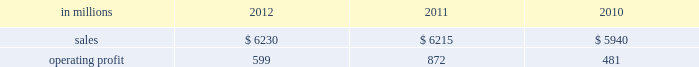Printing papers demand for printing papers products is closely corre- lated with changes in commercial printing and advertising activity , direct mail volumes and , for uncoated cut-size products , with changes in white- collar employment levels that affect the usage of copy and laser printer paper .
Pulp is further affected by changes in currency rates that can enhance or disadvantage producers in different geographic regions .
Principal cost drivers include manufacturing efficiency , raw material and energy costs and freight costs .
Pr int ing papers net sales for 2012 were about flat with 2011 and increased 5% ( 5 % ) from 2010 .
Operat- ing profits in 2012 were 31% ( 31 % ) lower than in 2011 , but 25% ( 25 % ) higher than in 2010 .
Excluding facility closure costs and impairment costs , operating profits in 2012 were 30% ( 30 % ) lower than in 2011 and 25% ( 25 % ) lower than in 2010 .
Benefits from higher sales volumes ( $ 58 mil- lion ) were more than offset by lower sales price real- izations and an unfavorable product mix ( $ 233 million ) , higher operating costs ( $ 30 million ) , higher maintenance outage costs ( $ 17 million ) , higher input costs ( $ 32 million ) and other items ( $ 6 million ) .
In addition , operating profits in 2011 included a $ 24 million gain related to the announced repurposing of our franklin , virginia mill to produce fluff pulp and an $ 11 million impairment charge related to our inverurie , scotland mill that was closed in 2009 .
Printing papers .
North american pr int ing papers net sales were $ 2.7 billion in 2012 , $ 2.8 billion in 2011 and $ 2.8 billion in 2010 .
Operating profits in 2012 were $ 331 million compared with $ 423 million ( $ 399 million excluding a $ 24 million gain associated with the repurposing of our franklin , virginia mill ) in 2011 and $ 18 million ( $ 333 million excluding facility clo- sure costs ) in 2010 .
Sales volumes in 2012 were flat with 2011 .
Average sales margins were lower primarily due to lower export sales prices and higher export sales volume .
Input costs were higher for wood and chemicals , but were partially offset by lower purchased pulp costs .
Freight costs increased due to higher oil prices .
Manufacturing operating costs were favorable reflecting strong mill performance .
Planned main- tenance downtime costs were slightly higher in 2012 .
No market-related downtime was taken in either 2012 or 2011 .
Entering the first quarter of 2013 , sales volumes are expected to increase compared with the fourth quar- ter of 2012 reflecting seasonally stronger demand .
Average sales price realizations are expected to be relatively flat as sales price realizations for domestic and export uncoated freesheet roll and cutsize paper should be stable .
Input costs should increase for energy , chemicals and wood .
Planned maintenance downtime costs are expected to be about $ 19 million lower with an outage scheduled at our georgetown mill versus outages at our courtland and eastover mills in the fourth quarter of 2012 .
Braz i l ian papers net sales for 2012 were $ 1.1 bil- lion compared with $ 1.2 billion in 2011 and $ 1.1 bil- lion in 2010 .
Operating profits for 2012 were $ 163 million compared with $ 169 million in 2011 and $ 159 million in 2010 .
Sales volumes in 2012 were higher than in 2011 as international paper improved its segment position in the brazilian market despite weaker year-over-year conditions in most markets .
Average sales price realizations improved for domestic uncoated freesheet paper , but the benefit was more than offset by declining prices for exported paper .
Margins were favorably affected by an increased proportion of sales to the higher- margin domestic market .
Raw material costs increased for wood and chemicals , but costs for purchased pulp decreased .
Operating costs and planned maintenance downtime costs were lower than in 2011 .
Looking ahead to 2013 , sales volumes in the first quarter are expected to be lower than in the fourth quarter of 2012 due to seasonally weaker customer demand for uncoated freesheet paper .
Average sales price realizations are expected to increase in the brazilian domestic market due to the realization of an announced sales price increase for uncoated free- sheet paper , but the benefit should be partially offset by pricing pressures in export markets .
Average sales margins are expected to be negatively impacted by a less favorable geographic mix .
Input costs are expected to be about flat due to lower energy costs being offset by higher costs for wood , purchased pulp , chemicals and utilities .
Planned maintenance outage costs should be $ 4 million lower with no outages scheduled in the first quarter .
Operating costs should be favorably impacted by the savings generated by the start-up of a new biomass boiler at the mogi guacu mill .
European papers net sales in 2012 were $ 1.4 bil- lion compared with $ 1.4 billion in 2011 and $ 1.3 bil- lion in 2010 .
Operating profits in 2012 were $ 179 million compared with $ 196 million ( $ 207 million excluding asset impairment charges related to our inverurie , scotland mill which was closed in 2009 ) in 2011 and $ 197 million ( $ 199 million excluding an asset impairment charge ) in 2010 .
Sales volumes in 2012 compared with 2011 were higher for uncoated freesheet paper in both europe and russia , while sales volumes for pulp were lower in both regions .
Average sales price realizations for uncoated .
What percentage of printing paper sales where north american printing papers sales in 2012? 
Computations: ((2.7 * 1000) / 6230)
Answer: 0.43339. 